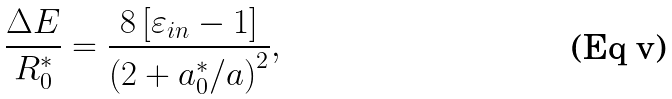<formula> <loc_0><loc_0><loc_500><loc_500>\frac { \Delta E } { R _ { 0 } ^ { * } } = \frac { 8 \left [ \varepsilon _ { i n } - 1 \right ] } { \left ( 2 + a _ { 0 } ^ { * } / a \right ) ^ { 2 } } ,</formula> 